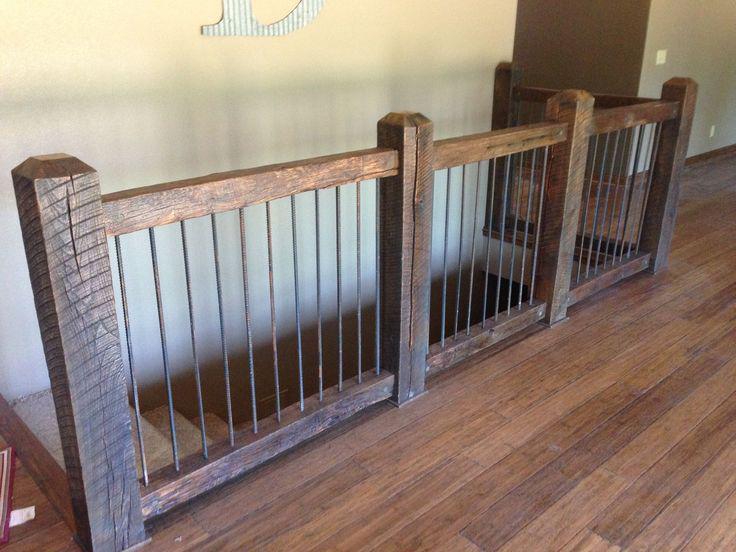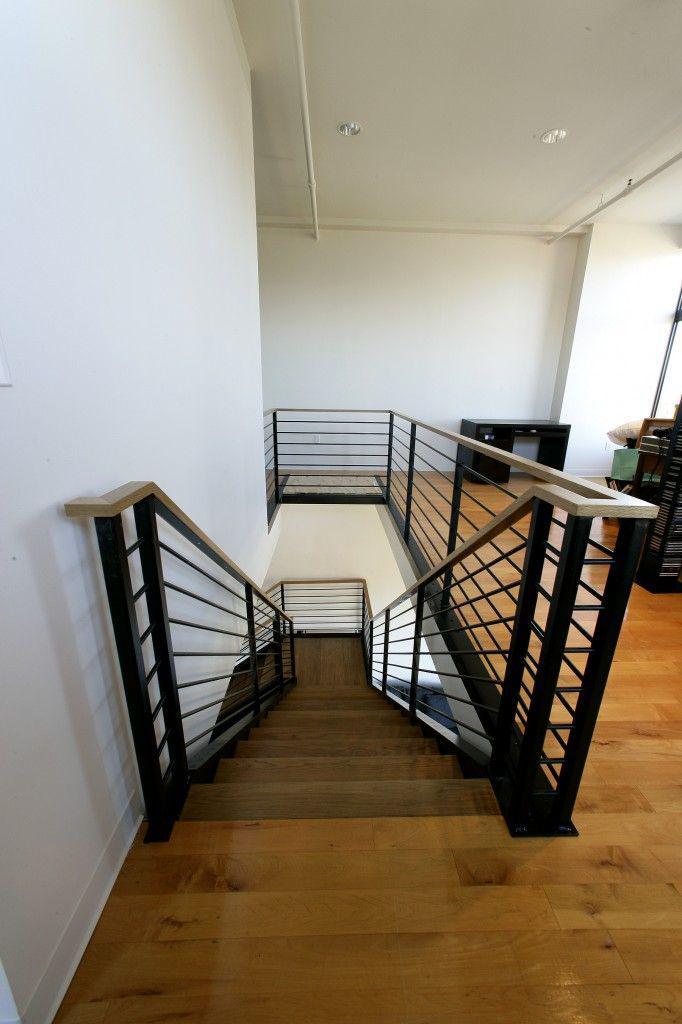The first image is the image on the left, the second image is the image on the right. For the images shown, is this caption "In at least one image there is a brown wooden floor at the bottom of the staircase." true? Answer yes or no. No. 